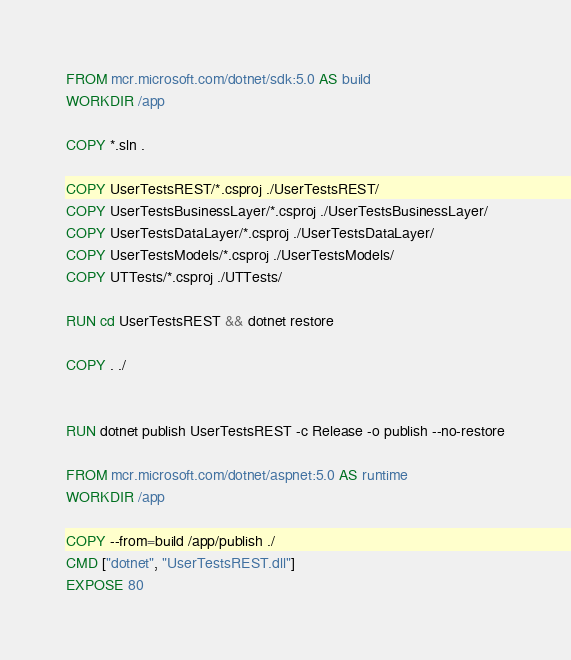Convert code to text. <code><loc_0><loc_0><loc_500><loc_500><_Dockerfile_>FROM mcr.microsoft.com/dotnet/sdk:5.0 AS build
WORKDIR /app

COPY *.sln .

COPY UserTestsREST/*.csproj ./UserTestsREST/
COPY UserTestsBusinessLayer/*.csproj ./UserTestsBusinessLayer/
COPY UserTestsDataLayer/*.csproj ./UserTestsDataLayer/
COPY UserTestsModels/*.csproj ./UserTestsModels/
COPY UTTests/*.csproj ./UTTests/

RUN cd UserTestsREST && dotnet restore

COPY . ./


RUN dotnet publish UserTestsREST -c Release -o publish --no-restore

FROM mcr.microsoft.com/dotnet/aspnet:5.0 AS runtime
WORKDIR /app 

COPY --from=build /app/publish ./
CMD ["dotnet", "UserTestsREST.dll"]
EXPOSE 80</code> 